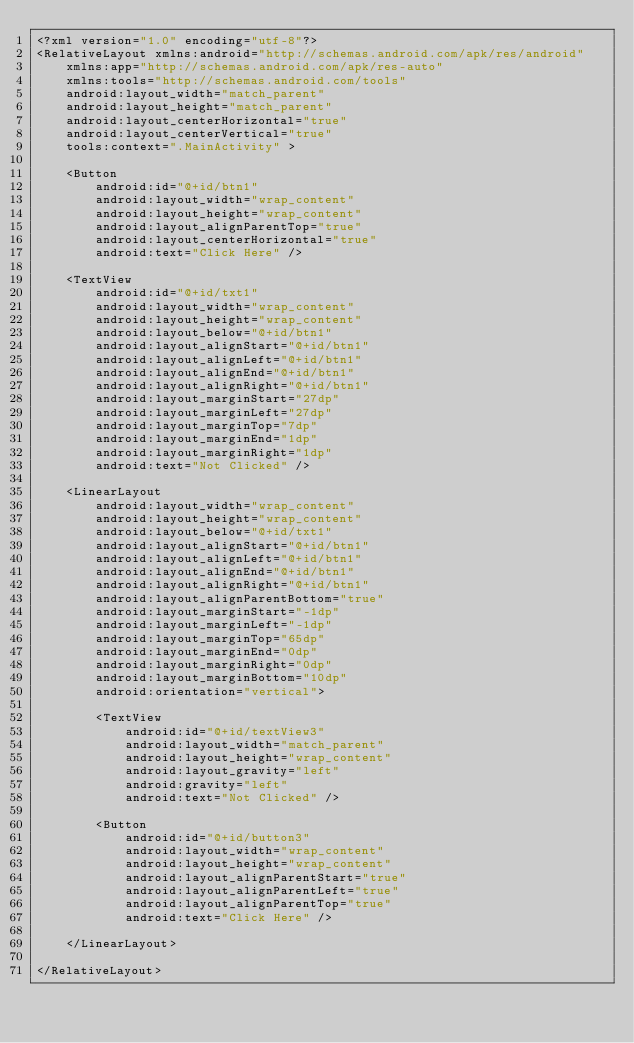Convert code to text. <code><loc_0><loc_0><loc_500><loc_500><_XML_><?xml version="1.0" encoding="utf-8"?>
<RelativeLayout xmlns:android="http://schemas.android.com/apk/res/android"
    xmlns:app="http://schemas.android.com/apk/res-auto"
    xmlns:tools="http://schemas.android.com/tools"
    android:layout_width="match_parent"
    android:layout_height="match_parent"
    android:layout_centerHorizontal="true"
    android:layout_centerVertical="true"
    tools:context=".MainActivity" >

    <Button
        android:id="@+id/btn1"
        android:layout_width="wrap_content"
        android:layout_height="wrap_content"
        android:layout_alignParentTop="true"
        android:layout_centerHorizontal="true"
        android:text="Click Here" />

    <TextView
        android:id="@+id/txt1"
        android:layout_width="wrap_content"
        android:layout_height="wrap_content"
        android:layout_below="@+id/btn1"
        android:layout_alignStart="@+id/btn1"
        android:layout_alignLeft="@+id/btn1"
        android:layout_alignEnd="@+id/btn1"
        android:layout_alignRight="@+id/btn1"
        android:layout_marginStart="27dp"
        android:layout_marginLeft="27dp"
        android:layout_marginTop="7dp"
        android:layout_marginEnd="1dp"
        android:layout_marginRight="1dp"
        android:text="Not Clicked" />

    <LinearLayout
        android:layout_width="wrap_content"
        android:layout_height="wrap_content"
        android:layout_below="@+id/txt1"
        android:layout_alignStart="@+id/btn1"
        android:layout_alignLeft="@+id/btn1"
        android:layout_alignEnd="@+id/btn1"
        android:layout_alignRight="@+id/btn1"
        android:layout_alignParentBottom="true"
        android:layout_marginStart="-1dp"
        android:layout_marginLeft="-1dp"
        android:layout_marginTop="65dp"
        android:layout_marginEnd="0dp"
        android:layout_marginRight="0dp"
        android:layout_marginBottom="10dp"
        android:orientation="vertical">

        <TextView
            android:id="@+id/textView3"
            android:layout_width="match_parent"
            android:layout_height="wrap_content"
            android:layout_gravity="left"
            android:gravity="left"
            android:text="Not Clicked" />

        <Button
            android:id="@+id/button3"
            android:layout_width="wrap_content"
            android:layout_height="wrap_content"
            android:layout_alignParentStart="true"
            android:layout_alignParentLeft="true"
            android:layout_alignParentTop="true"
            android:text="Click Here" />

    </LinearLayout>

</RelativeLayout></code> 